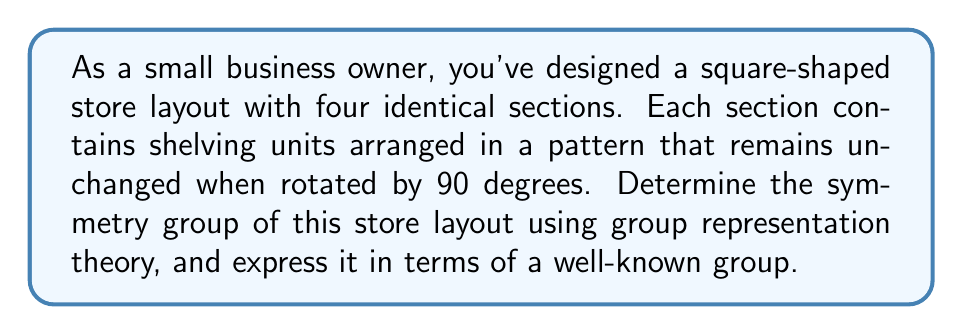What is the answer to this math problem? Let's approach this step-by-step:

1) First, we need to identify the symmetries of the store layout:
   - Rotations: 0°, 90°, 180°, 270° (clockwise)
   - Reflections: across two diagonals and two midlines

2) These symmetries form a group. Let's count the elements:
   - 4 rotations (including identity)
   - 4 reflections
   Total: 8 elements

3) This group of 8 elements is isomorphic to the dihedral group $D_4$, which is the symmetry group of a square.

4) In representation theory, we can describe this group using matrices. Let's use the standard 2D representation:

   Rotations:
   $$R_0 = \begin{pmatrix} 1 & 0 \\ 0 & 1 \end{pmatrix}, R_{90} = \begin{pmatrix} 0 & -1 \\ 1 & 0 \end{pmatrix}$$
   $$R_{180} = \begin{pmatrix} -1 & 0 \\ 0 & -1 \end{pmatrix}, R_{270} = \begin{pmatrix} 0 & 1 \\ -1 & 0 \end{pmatrix}$$

   Reflections:
   $$M_x = \begin{pmatrix} 1 & 0 \\ 0 & -1 \end{pmatrix}, M_y = \begin{pmatrix} -1 & 0 \\ 0 & 1 \end{pmatrix}$$
   $$M_d = \begin{pmatrix} 0 & 1 \\ 1 & 0 \end{pmatrix}, M_{-d} = \begin{pmatrix} 0 & -1 \\ -1 & 0 \end{pmatrix}$$

5) The character table for $D_4$ is:

   $$\begin{array}{c|ccccc}
      & E & C_4 & C_2 & C_2' & \sigma_v \\
   \hline
   A_1 & 1 & 1 & 1 & 1 & 1 \\
   A_2 & 1 & 1 & 1 & -1 & -1 \\
   B_1 & 1 & -1 & 1 & 1 & -1 \\
   B_2 & 1 & -1 & 1 & -1 & 1 \\
   E & 2 & 0 & -2 & 0 & 0
   \end{array}$$

   Where $E$ is identity, $C_4$ is 90° rotation, $C_2$ is 180° rotation, $C_2'$ is 180° rotation around diagonal, and $\sigma_v$ is reflection.

6) The 2D representation we used is the $E$ irreducible representation in this character table.

Therefore, the symmetry group of the store layout is the dihedral group $D_4$, represented by the 2D irreducible representation $E$ in its character table.
Answer: $D_4$ 